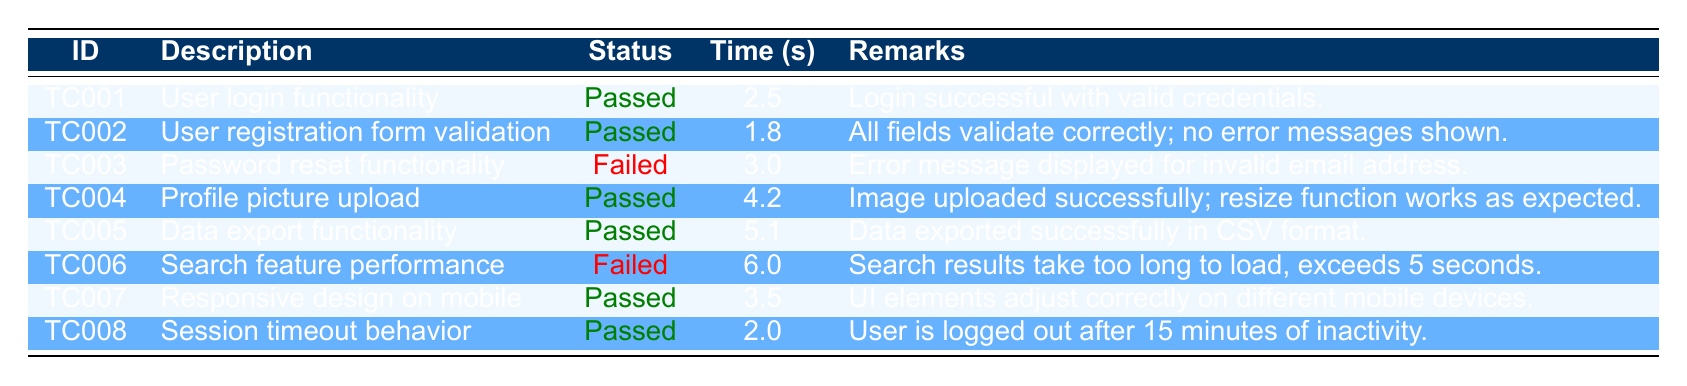What is the status of the user login functionality test case? The status of the test case with ID TC001, which describes the user login functionality, is "Passed." This is found in the "Status" column of the table under the relevant test case description.
Answer: Passed What was the longest execution time recorded for any of the test cases? Looking through the "Time (s)" column, the longest execution time is recorded for the "Search feature performance" test case (TC006) with an execution time of 6.0 seconds.
Answer: 6.0 seconds How many test cases failed in total? There are two test cases with the status "Failed." They are TC003 ("Password reset functionality") and TC006 ("Search feature performance"). By counting these, we determine the total number of failures.
Answer: 2 What is the average execution time of all the test cases? To find the average, first, sum the execution times: 2.5 + 1.8 + 3.0 + 4.2 + 5.1 + 6.0 + 3.5 + 2.0 = 28.1 seconds. There are 8 test cases, so the average execution time is 28.1 divided by 8, which equals 3.5125 seconds (approximately 3.51 seconds when rounded).
Answer: 3.51 seconds Do any test cases list remarks indicating a successful upload? Yes, the test case for "Profile picture upload" (TC004) indicates that the image was uploaded successfully. The remarks column states that the image was uploaded successfully, thus affirming this fact.
Answer: Yes Which test case had the quickest execution time, and what was that time? The test case with the quickest execution time is TC002 ("User registration form validation"), with an execution time of 1.8 seconds. Checking the "Time (s)" column confirms this.
Answer: TC002, 1.8 seconds Is there any test case that has remarks indicating a timeout issue? No, none of the test cases indicate any timeout issues in their remarks. All remarks relate positively to successful processes or validation, except for TC006 which mentions slow search results.
Answer: No Which test case indicates that a user will be logged out after a specific period? The "Session timeout behavior" test case (TC008) indicates that users are logged out after 15 minutes of inactivity. This information is included in the remarks section.
Answer: TC008 - 15 minutes 